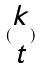<formula> <loc_0><loc_0><loc_500><loc_500>( \begin{matrix} k \\ t \end{matrix} )</formula> 